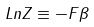<formula> <loc_0><loc_0><loc_500><loc_500>L n Z \equiv - F \beta</formula> 